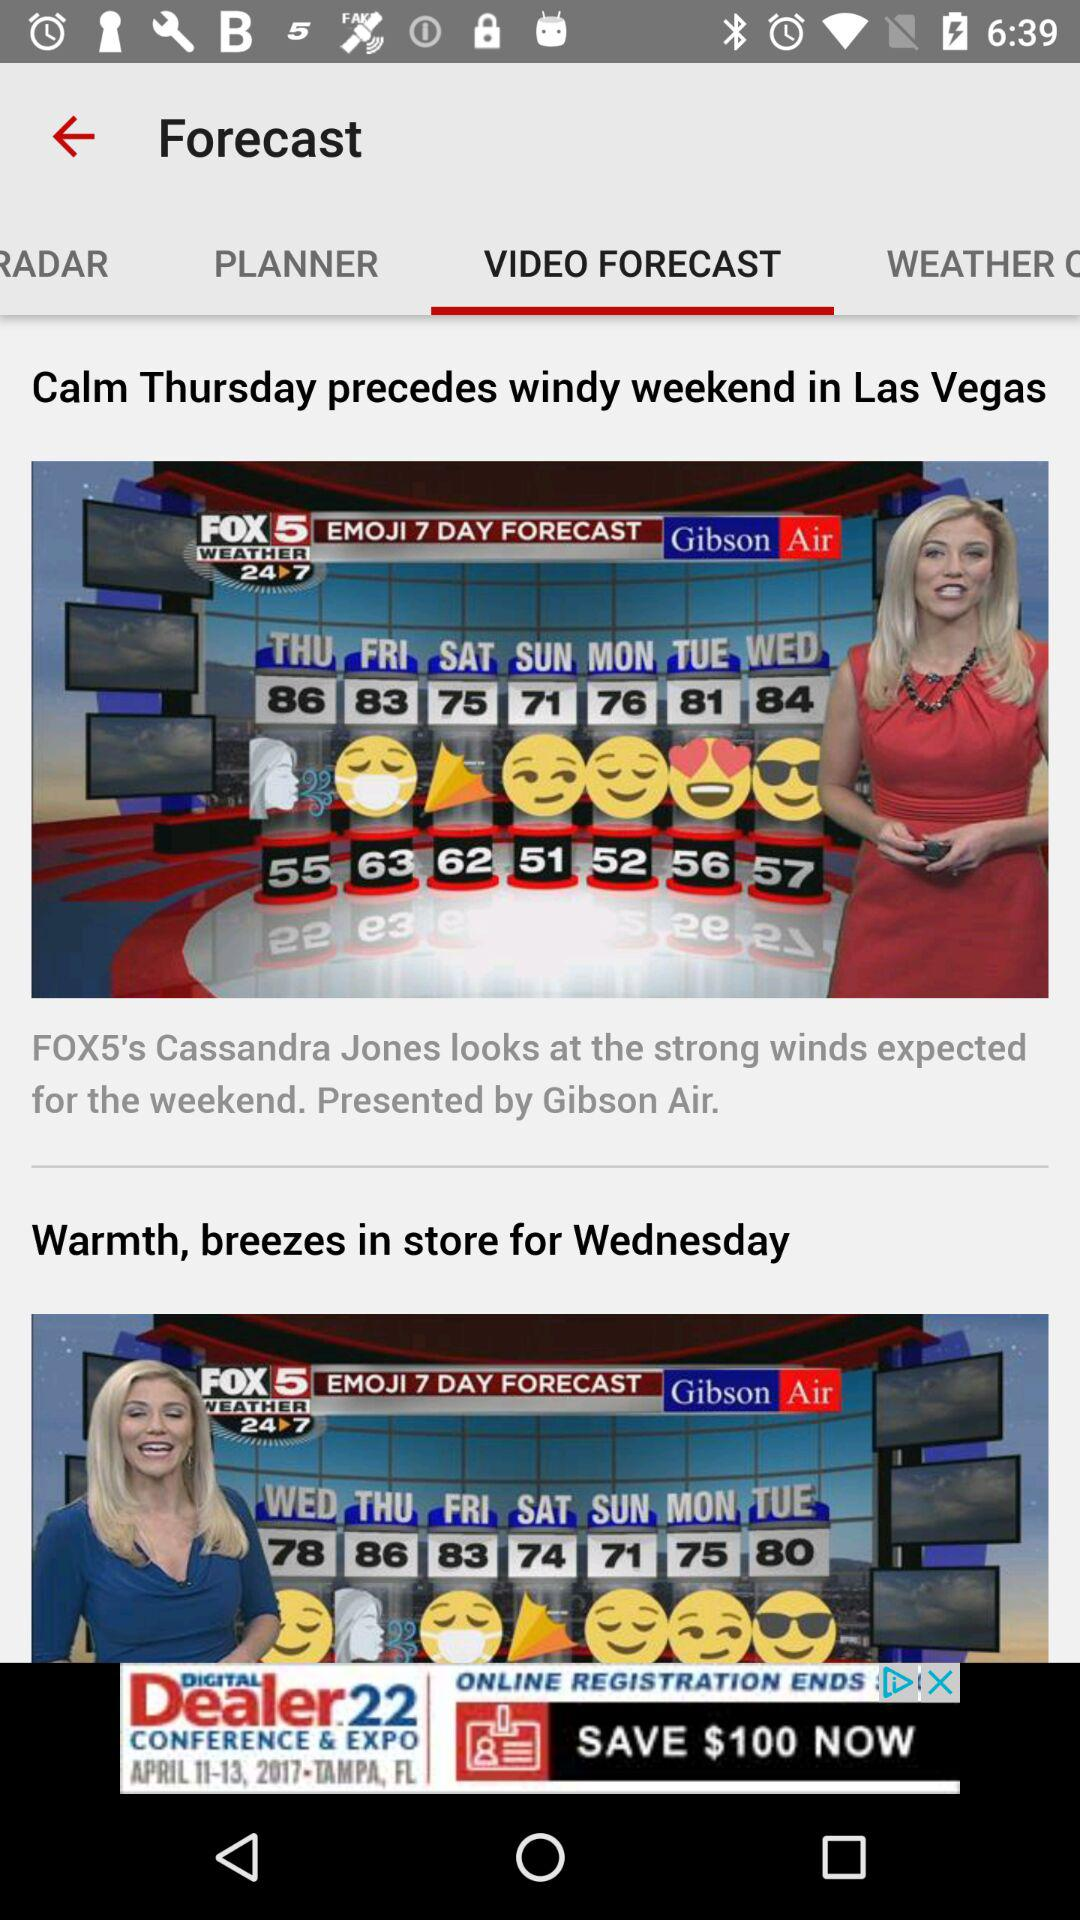What is the application name? The application name is "Las Vegas Weather Radar-Fox5". 